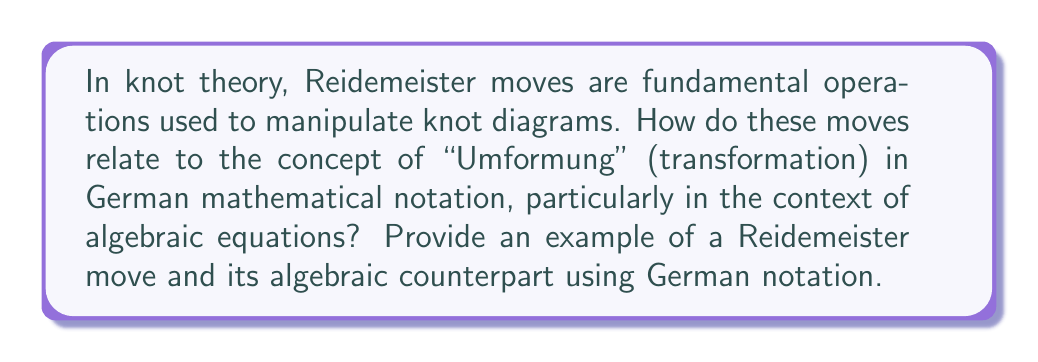What is the answer to this math problem? To answer this question, let's break it down into steps:

1. Reidemeister moves:
   There are three types of Reidemeister moves:
   - Type I: Adding or removing a twist in the knot
   - Type II: Moving one strand completely over another
   - Type III: Moving a strand over or under a crossing

2. German mathematical notation:
   In German mathematics, "Umformung" refers to the transformation or manipulation of mathematical expressions, particularly equations.

3. Relating Reidemeister moves to algebraic transformations:
   Let's consider the Type I Reidemeister move and relate it to an algebraic transformation.

4. Example of a Type I Reidemeister move:
   [asy]
   import geometry;
   
   draw((0,0)--(1,1), arrow=Arrow);
   draw((1,1)--(2,0));
   
   draw((4,0)--(5,1), arrow=Arrow);
   draw((5,1)--(6,0));
   draw((5,0.5){dir(45)}..{dir(-45)}(5.5,0.5));
   
   label("$\longleftrightarrow$", (3,0.5));
   [/asy]

5. Algebraic counterpart using German notation:
   Consider the equation:
   $$x + 0 = x$$
   
   In German notation, we can write this transformation as:
   $$x + 0 \xrightarrow{\text{Umformung}} x$$

6. Explanation of the relation:
   The Type I Reidemeister move adds or removes a trivial twist in the knot, which doesn't change the knot's fundamental structure. Similarly, adding or removing zero in an algebraic equation doesn't change the equation's solution or meaning.

7. Importance in both contexts:
   Both the Reidemeister move and the algebraic transformation simplify the representation without changing the underlying structure or solution.
Answer: Type I Reidemeister move $\sim$ $x + 0 \xrightarrow{\text{Umformung}} x$ 